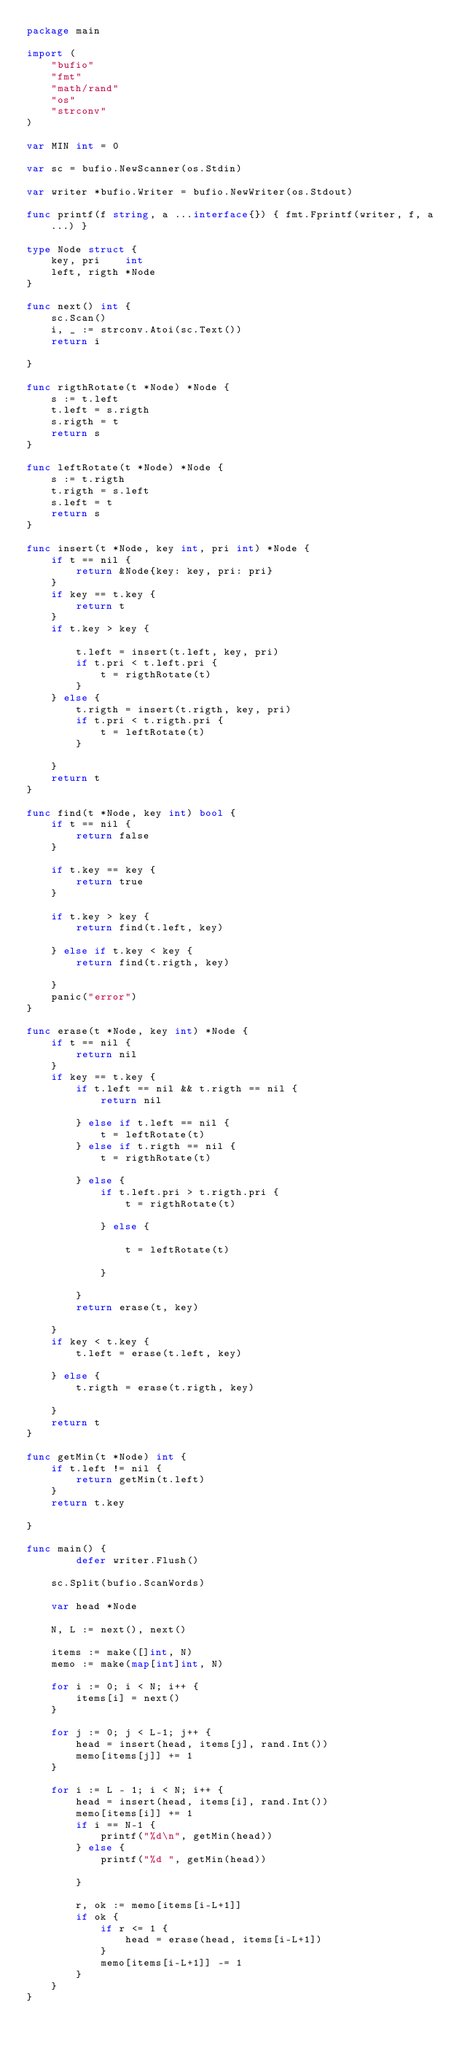<code> <loc_0><loc_0><loc_500><loc_500><_Go_>package main

import (
	"bufio"
	"fmt"
	"math/rand"
	"os"
	"strconv"
)

var MIN int = 0

var sc = bufio.NewScanner(os.Stdin)

var writer *bufio.Writer = bufio.NewWriter(os.Stdout)

func printf(f string, a ...interface{}) { fmt.Fprintf(writer, f, a...) }

type Node struct {
	key, pri    int
	left, rigth *Node
}

func next() int {
	sc.Scan()
	i, _ := strconv.Atoi(sc.Text())
	return i

}

func rigthRotate(t *Node) *Node {
	s := t.left
	t.left = s.rigth
	s.rigth = t
	return s
}

func leftRotate(t *Node) *Node {
	s := t.rigth
	t.rigth = s.left
	s.left = t
	return s
}

func insert(t *Node, key int, pri int) *Node {
	if t == nil {
		return &Node{key: key, pri: pri}
	}
	if key == t.key {
		return t
	}
	if t.key > key {

		t.left = insert(t.left, key, pri)
		if t.pri < t.left.pri {
			t = rigthRotate(t)
		}
	} else {
		t.rigth = insert(t.rigth, key, pri)
		if t.pri < t.rigth.pri {
			t = leftRotate(t)
		}

	}
	return t
}

func find(t *Node, key int) bool {
	if t == nil {
		return false
	}

	if t.key == key {
		return true
	}

	if t.key > key {
		return find(t.left, key)

	} else if t.key < key {
		return find(t.rigth, key)

	}
	panic("error")
}

func erase(t *Node, key int) *Node {
	if t == nil {
		return nil
	}
	if key == t.key {
		if t.left == nil && t.rigth == nil {
			return nil

		} else if t.left == nil {
			t = leftRotate(t)
		} else if t.rigth == nil {
			t = rigthRotate(t)

		} else {
			if t.left.pri > t.rigth.pri {
				t = rigthRotate(t)

			} else {

				t = leftRotate(t)

			}

		}
		return erase(t, key)

	}
	if key < t.key {
		t.left = erase(t.left, key)

	} else {
		t.rigth = erase(t.rigth, key)

	}
	return t
}

func getMin(t *Node) int {
	if t.left != nil {
		return getMin(t.left)
	}
	return t.key

}

func main() {
    	defer writer.Flush()

	sc.Split(bufio.ScanWords)

	var head *Node

	N, L := next(), next()

	items := make([]int, N)
	memo := make(map[int]int, N)

	for i := 0; i < N; i++ {
		items[i] = next()
	}

	for j := 0; j < L-1; j++ {
		head = insert(head, items[j], rand.Int())
		memo[items[j]] += 1
	}

	for i := L - 1; i < N; i++ {
		head = insert(head, items[i], rand.Int())
		memo[items[i]] += 1
		if i == N-1 {
			printf("%d\n", getMin(head))
		} else {
			printf("%d ", getMin(head))

		}

		r, ok := memo[items[i-L+1]]
		if ok {
			if r <= 1 {
				head = erase(head, items[i-L+1])
			}
			memo[items[i-L+1]] -= 1
		}
	}
}


</code> 